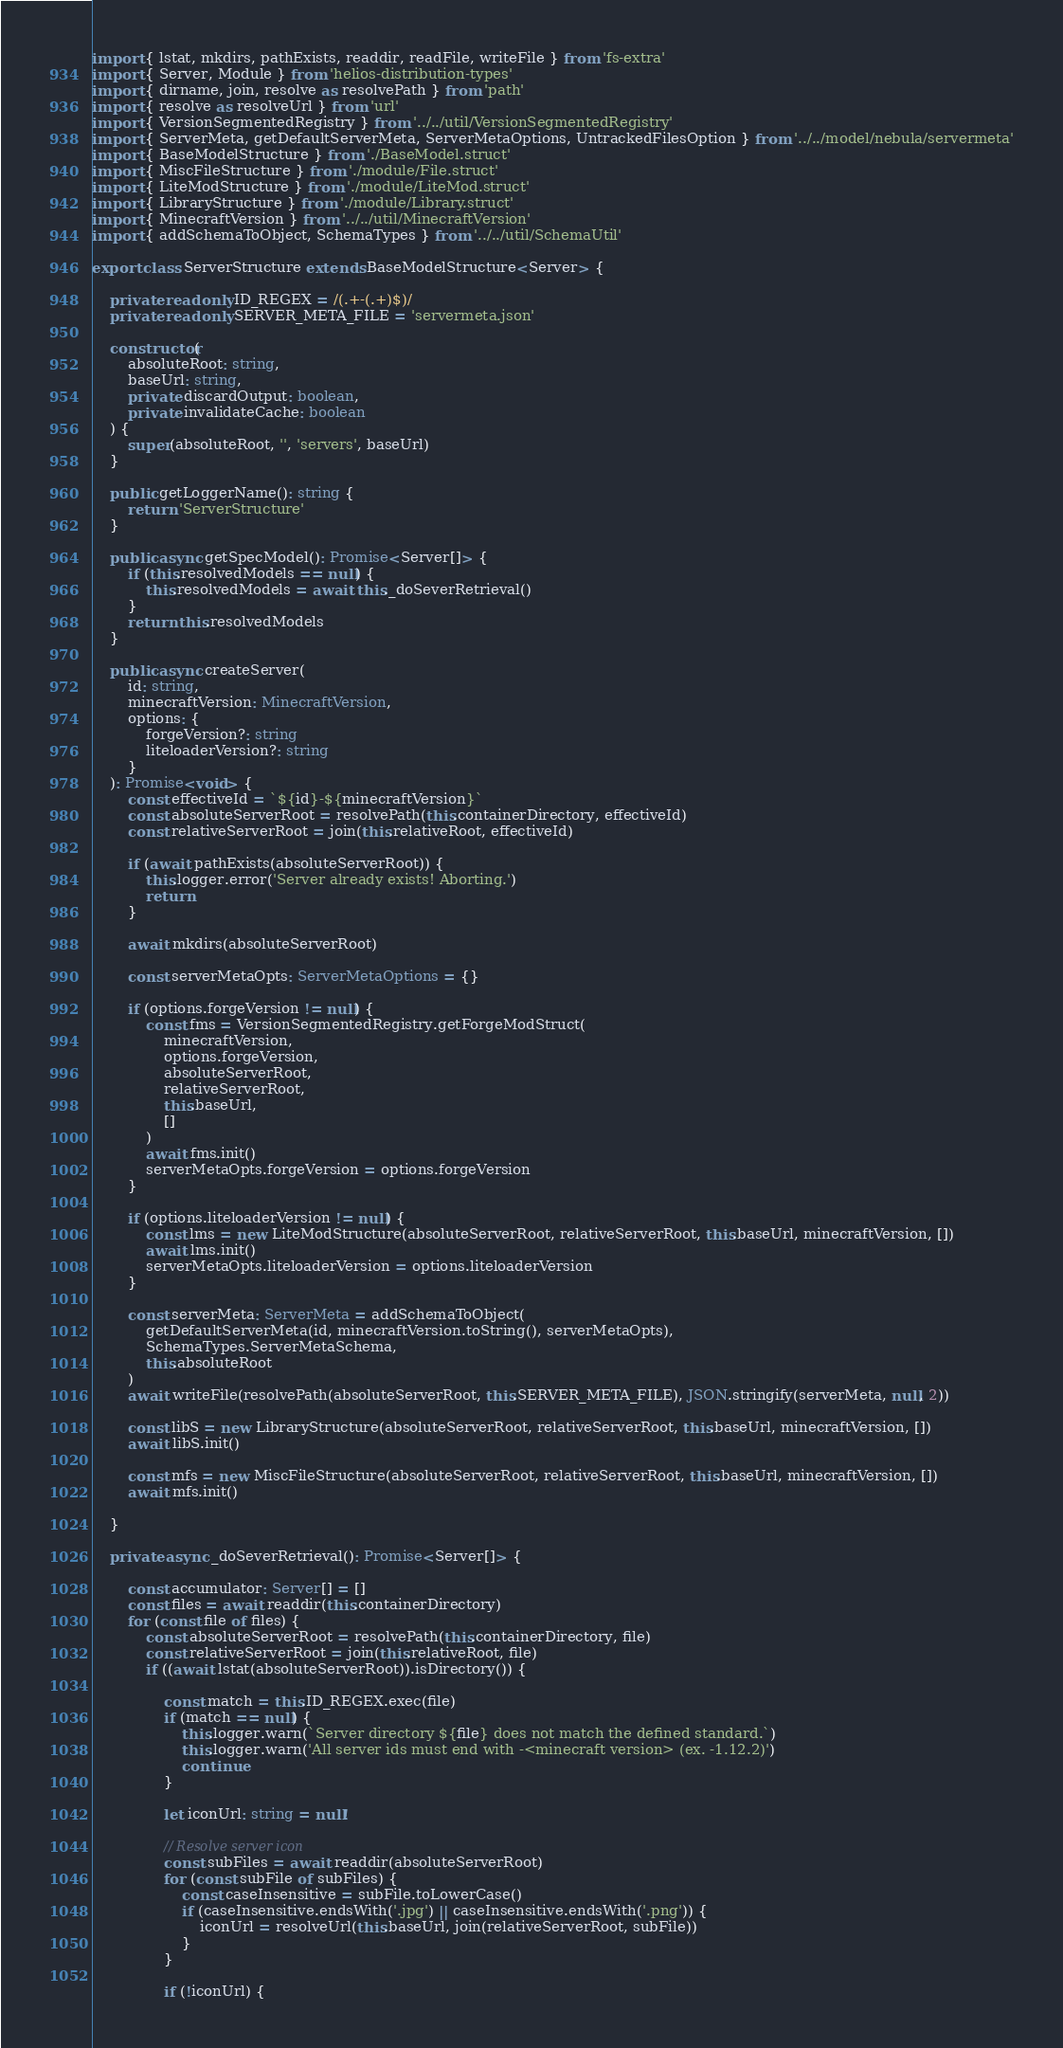<code> <loc_0><loc_0><loc_500><loc_500><_TypeScript_>import { lstat, mkdirs, pathExists, readdir, readFile, writeFile } from 'fs-extra'
import { Server, Module } from 'helios-distribution-types'
import { dirname, join, resolve as resolvePath } from 'path'
import { resolve as resolveUrl } from 'url'
import { VersionSegmentedRegistry } from '../../util/VersionSegmentedRegistry'
import { ServerMeta, getDefaultServerMeta, ServerMetaOptions, UntrackedFilesOption } from '../../model/nebula/servermeta'
import { BaseModelStructure } from './BaseModel.struct'
import { MiscFileStructure } from './module/File.struct'
import { LiteModStructure } from './module/LiteMod.struct'
import { LibraryStructure } from './module/Library.struct'
import { MinecraftVersion } from '../../util/MinecraftVersion'
import { addSchemaToObject, SchemaTypes } from '../../util/SchemaUtil'

export class ServerStructure extends BaseModelStructure<Server> {

    private readonly ID_REGEX = /(.+-(.+)$)/
    private readonly SERVER_META_FILE = 'servermeta.json'

    constructor(
        absoluteRoot: string,
        baseUrl: string,
        private discardOutput: boolean,
        private invalidateCache: boolean
    ) {
        super(absoluteRoot, '', 'servers', baseUrl)
    }

    public getLoggerName(): string {
        return 'ServerStructure'
    }

    public async getSpecModel(): Promise<Server[]> {
        if (this.resolvedModels == null) {
            this.resolvedModels = await this._doSeverRetrieval()
        }
        return this.resolvedModels
    }

    public async createServer(
        id: string,
        minecraftVersion: MinecraftVersion,
        options: {
            forgeVersion?: string
            liteloaderVersion?: string
        }
    ): Promise<void> {
        const effectiveId = `${id}-${minecraftVersion}`
        const absoluteServerRoot = resolvePath(this.containerDirectory, effectiveId)
        const relativeServerRoot = join(this.relativeRoot, effectiveId)

        if (await pathExists(absoluteServerRoot)) {
            this.logger.error('Server already exists! Aborting.')
            return
        }

        await mkdirs(absoluteServerRoot)

        const serverMetaOpts: ServerMetaOptions = {}

        if (options.forgeVersion != null) {
            const fms = VersionSegmentedRegistry.getForgeModStruct(
                minecraftVersion,
                options.forgeVersion,
                absoluteServerRoot,
                relativeServerRoot,
                this.baseUrl,
                []
            )
            await fms.init()
            serverMetaOpts.forgeVersion = options.forgeVersion
        }

        if (options.liteloaderVersion != null) {
            const lms = new LiteModStructure(absoluteServerRoot, relativeServerRoot, this.baseUrl, minecraftVersion, [])
            await lms.init()
            serverMetaOpts.liteloaderVersion = options.liteloaderVersion
        }

        const serverMeta: ServerMeta = addSchemaToObject(
            getDefaultServerMeta(id, minecraftVersion.toString(), serverMetaOpts),
            SchemaTypes.ServerMetaSchema,
            this.absoluteRoot
        )
        await writeFile(resolvePath(absoluteServerRoot, this.SERVER_META_FILE), JSON.stringify(serverMeta, null, 2))

        const libS = new LibraryStructure(absoluteServerRoot, relativeServerRoot, this.baseUrl, minecraftVersion, [])
        await libS.init()

        const mfs = new MiscFileStructure(absoluteServerRoot, relativeServerRoot, this.baseUrl, minecraftVersion, [])
        await mfs.init()

    }

    private async _doSeverRetrieval(): Promise<Server[]> {

        const accumulator: Server[] = []
        const files = await readdir(this.containerDirectory)
        for (const file of files) {
            const absoluteServerRoot = resolvePath(this.containerDirectory, file)
            const relativeServerRoot = join(this.relativeRoot, file)
            if ((await lstat(absoluteServerRoot)).isDirectory()) {

                const match = this.ID_REGEX.exec(file)
                if (match == null) {
                    this.logger.warn(`Server directory ${file} does not match the defined standard.`)
                    this.logger.warn('All server ids must end with -<minecraft version> (ex. -1.12.2)')
                    continue
                }

                let iconUrl: string = null!

                // Resolve server icon
                const subFiles = await readdir(absoluteServerRoot)
                for (const subFile of subFiles) {
                    const caseInsensitive = subFile.toLowerCase()
                    if (caseInsensitive.endsWith('.jpg') || caseInsensitive.endsWith('.png')) {
                        iconUrl = resolveUrl(this.baseUrl, join(relativeServerRoot, subFile))
                    }
                }

                if (!iconUrl) {</code> 